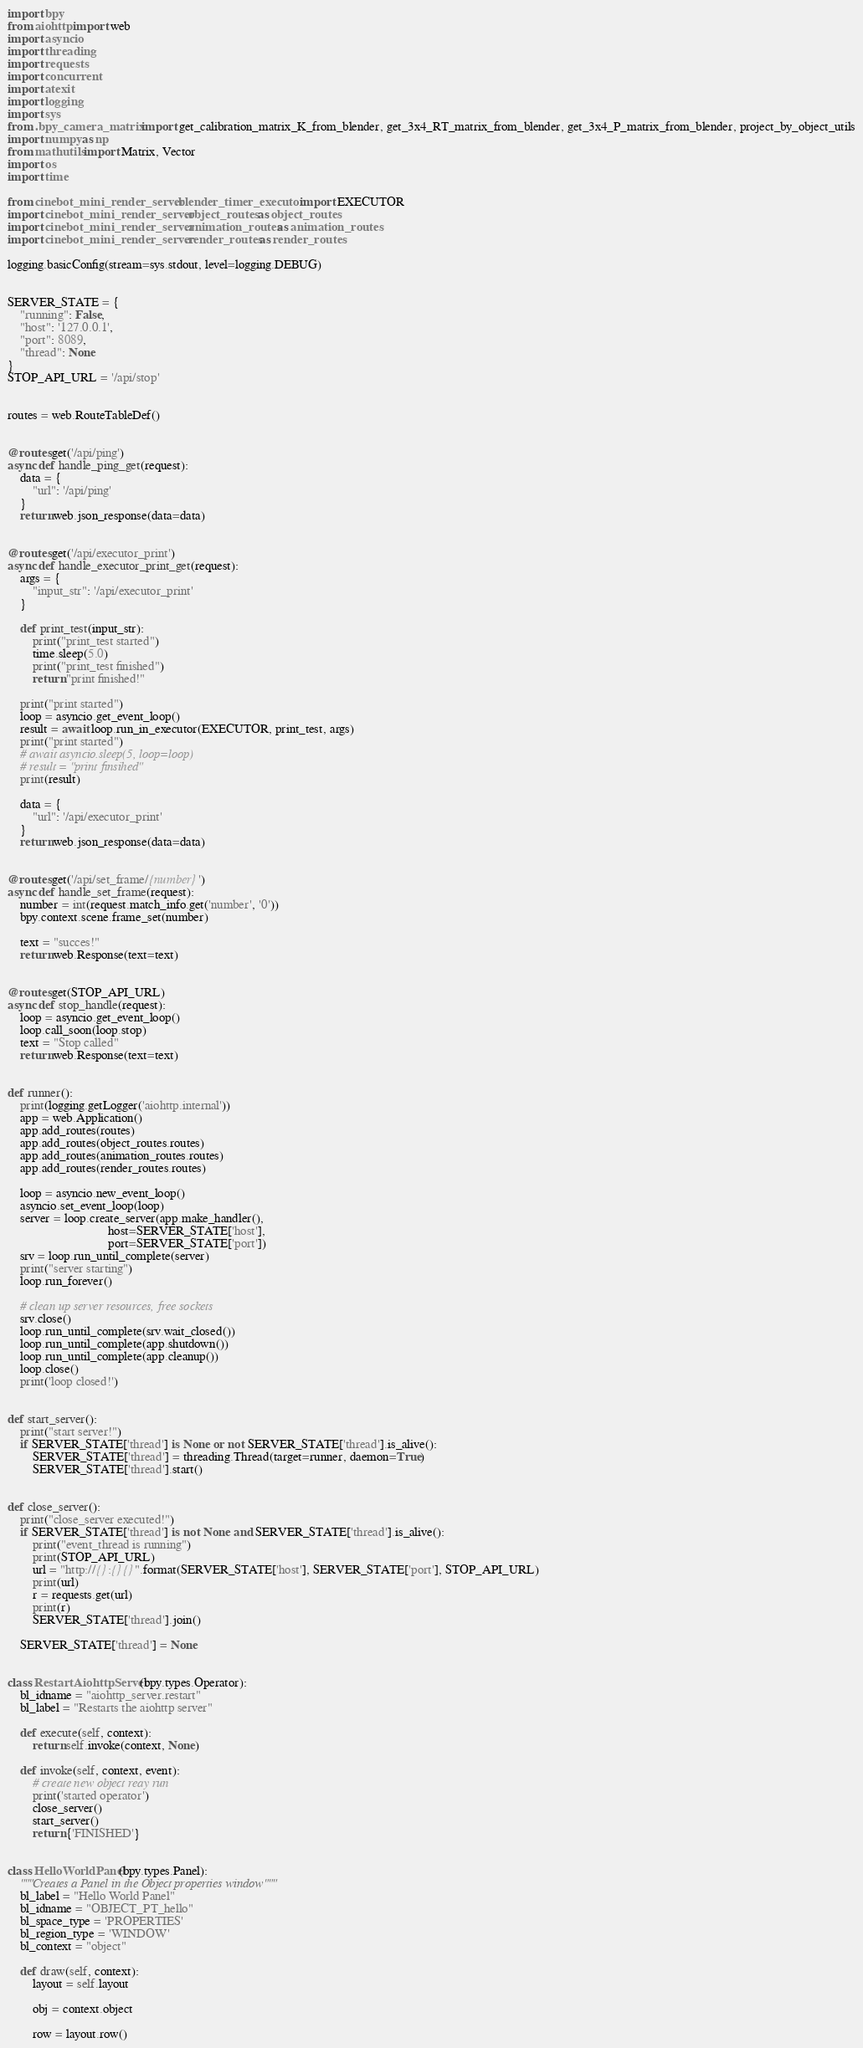<code> <loc_0><loc_0><loc_500><loc_500><_Python_>import bpy
from aiohttp import web
import asyncio
import threading
import requests
import concurrent
import atexit
import logging
import sys
from .bpy_camera_matrix import get_calibration_matrix_K_from_blender, get_3x4_RT_matrix_from_blender, get_3x4_P_matrix_from_blender, project_by_object_utils
import numpy as np
from mathutils import Matrix, Vector
import os
import time

from cinebot_mini_render_server.blender_timer_executor import EXECUTOR
import cinebot_mini_render_server.object_routes as object_routes
import cinebot_mini_render_server.animation_routes as animation_routes
import cinebot_mini_render_server.render_routes as render_routes

logging.basicConfig(stream=sys.stdout, level=logging.DEBUG)


SERVER_STATE = {
    "running": False,
    "host": '127.0.0.1',
    "port": 8089,
    "thread": None
}
STOP_API_URL = '/api/stop'


routes = web.RouteTableDef()


@routes.get('/api/ping')
async def handle_ping_get(request):
    data = {
        "url": '/api/ping'
    }
    return web.json_response(data=data)


@routes.get('/api/executor_print')
async def handle_executor_print_get(request):
    args = {
        "input_str": '/api/executor_print'
    }

    def print_test(input_str):
        print("print_test started")
        time.sleep(5.0)
        print("print_test finished")
        return "print finished!"
    
    print("print started")
    loop = asyncio.get_event_loop()
    result = await loop.run_in_executor(EXECUTOR, print_test, args)
    print("print started")
    # await asyncio.sleep(5, loop=loop)
    # result = "print finsihed"
    print(result)

    data = {
        "url": '/api/executor_print'
    }
    return web.json_response(data=data)


@routes.get('/api/set_frame/{number}')
async def handle_set_frame(request):
    number = int(request.match_info.get('number', '0'))
    bpy.context.scene.frame_set(number)

    text = "succes!"
    return web.Response(text=text)


@routes.get(STOP_API_URL)
async def stop_handle(request):
    loop = asyncio.get_event_loop()
    loop.call_soon(loop.stop)
    text = "Stop called"
    return web.Response(text=text)


def runner():
    print(logging.getLogger('aiohttp.internal'))
    app = web.Application()
    app.add_routes(routes)
    app.add_routes(object_routes.routes)
    app.add_routes(animation_routes.routes)
    app.add_routes(render_routes.routes)

    loop = asyncio.new_event_loop()
    asyncio.set_event_loop(loop)
    server = loop.create_server(app.make_handler(),
                                host=SERVER_STATE['host'],
                                port=SERVER_STATE['port'])
    srv = loop.run_until_complete(server)
    print("server starting")
    loop.run_forever()

    # clean up server resources, free sockets
    srv.close()
    loop.run_until_complete(srv.wait_closed())
    loop.run_until_complete(app.shutdown())
    loop.run_until_complete(app.cleanup())
    loop.close()
    print('loop closed!')


def start_server():
    print("start server!")
    if SERVER_STATE['thread'] is None or not SERVER_STATE['thread'].is_alive():
        SERVER_STATE['thread'] = threading.Thread(target=runner, daemon=True)
        SERVER_STATE['thread'].start()


def close_server():
    print("close_server executed!")
    if SERVER_STATE['thread'] is not None and SERVER_STATE['thread'].is_alive():
        print("event_thread is running")
        print(STOP_API_URL)
        url = "http://{}:{}{}".format(SERVER_STATE['host'], SERVER_STATE['port'], STOP_API_URL)
        print(url)
        r = requests.get(url)
        print(r)
        SERVER_STATE['thread'].join()
    
    SERVER_STATE['thread'] = None


class RestartAiohttpServer(bpy.types.Operator):
    bl_idname = "aiohttp_server.restart"
    bl_label = "Restarts the aiohttp server"
    
    def execute(self, context):
        return self.invoke(context, None)

    def invoke(self, context, event):
        # create new object reay run
        print('started operator')
        close_server()
        start_server()
        return {'FINISHED'}


class HelloWorldPanel(bpy.types.Panel):
    """Creates a Panel in the Object properties window"""
    bl_label = "Hello World Panel"
    bl_idname = "OBJECT_PT_hello"
    bl_space_type = 'PROPERTIES'
    bl_region_type = 'WINDOW'
    bl_context = "object"

    def draw(self, context):
        layout = self.layout

        obj = context.object

        row = layout.row()</code> 